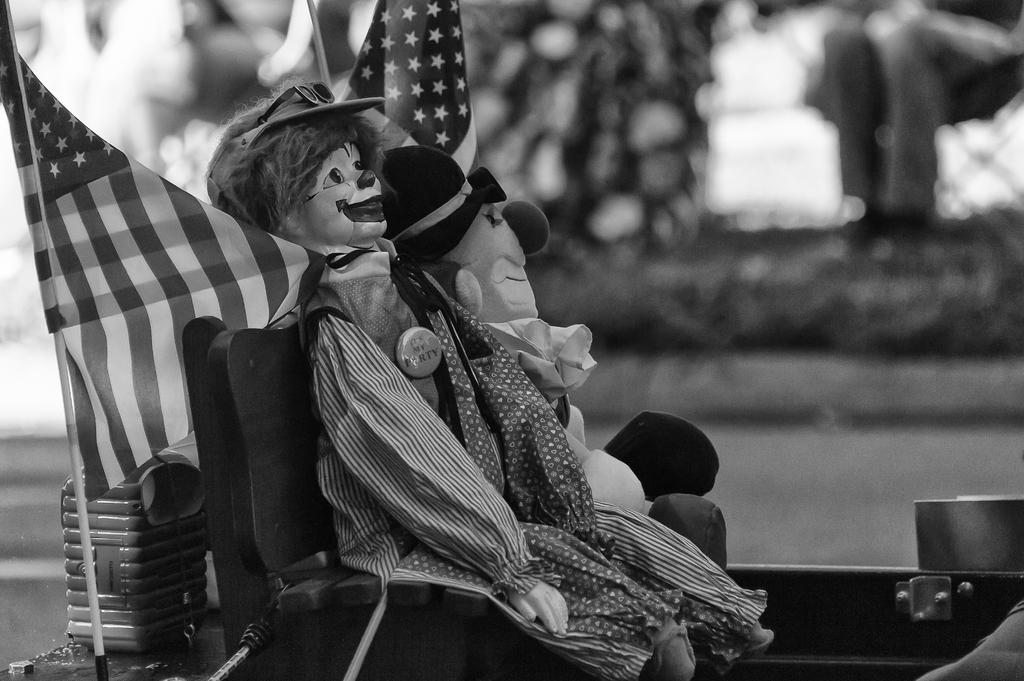What is the color scheme of the image? The image is black and white. What type of objects can be seen in the image? There are toys, chairs, flags, and a stick in the image. Can you describe the background of the image? The background has a blurred view. What type of badge is being worn by the toy in the image? There are no badges present in the image. What type of jewel is being held by the stick in the image? There are no jewels present in the image. 